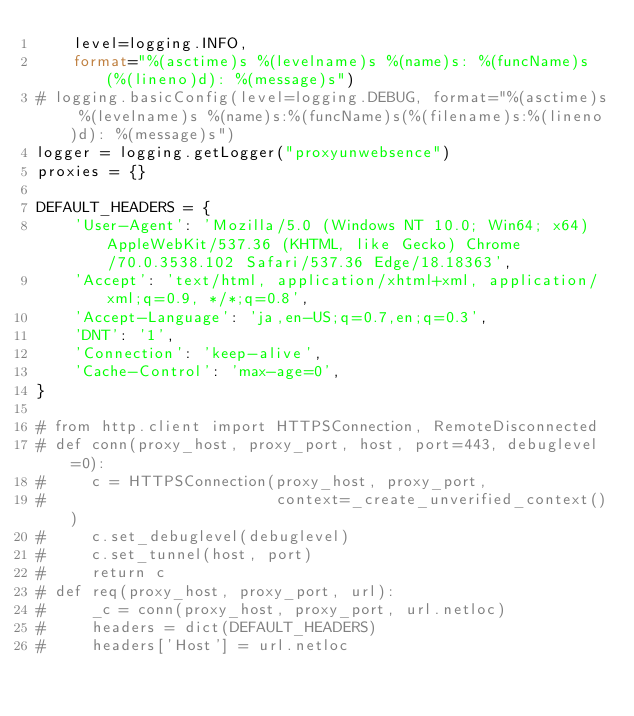<code> <loc_0><loc_0><loc_500><loc_500><_Python_>    level=logging.INFO,
    format="%(asctime)s %(levelname)s %(name)s: %(funcName)s(%(lineno)d): %(message)s")
# logging.basicConfig(level=logging.DEBUG, format="%(asctime)s %(levelname)s %(name)s:%(funcName)s(%(filename)s:%(lineno)d): %(message)s")
logger = logging.getLogger("proxyunwebsence")
proxies = {}

DEFAULT_HEADERS = {
    'User-Agent': 'Mozilla/5.0 (Windows NT 10.0; Win64; x64) AppleWebKit/537.36 (KHTML, like Gecko) Chrome/70.0.3538.102 Safari/537.36 Edge/18.18363',
    'Accept': 'text/html, application/xhtml+xml, application/xml;q=0.9, */*;q=0.8',
    'Accept-Language': 'ja,en-US;q=0.7,en;q=0.3',
    'DNT': '1',
    'Connection': 'keep-alive',
    'Cache-Control': 'max-age=0',
}

# from http.client import HTTPSConnection, RemoteDisconnected
# def conn(proxy_host, proxy_port, host, port=443, debuglevel=0):
#     c = HTTPSConnection(proxy_host, proxy_port,
#                         context=_create_unverified_context())
#     c.set_debuglevel(debuglevel)
#     c.set_tunnel(host, port)
#     return c
# def req(proxy_host, proxy_port, url):
#     _c = conn(proxy_host, proxy_port, url.netloc)
#     headers = dict(DEFAULT_HEADERS)
#     headers['Host'] = url.netloc</code> 